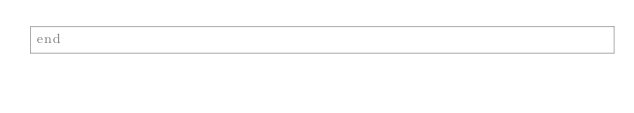<code> <loc_0><loc_0><loc_500><loc_500><_Crystal_>end
</code> 